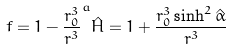Convert formula to latex. <formula><loc_0><loc_0><loc_500><loc_500>f = 1 - \frac { r _ { 0 } ^ { 3 } } { r ^ { 3 } } ^ { a } \hat { H } = 1 + \frac { r _ { 0 } ^ { 3 } \sinh ^ { 2 } \hat { \alpha } } { r ^ { 3 } }</formula> 